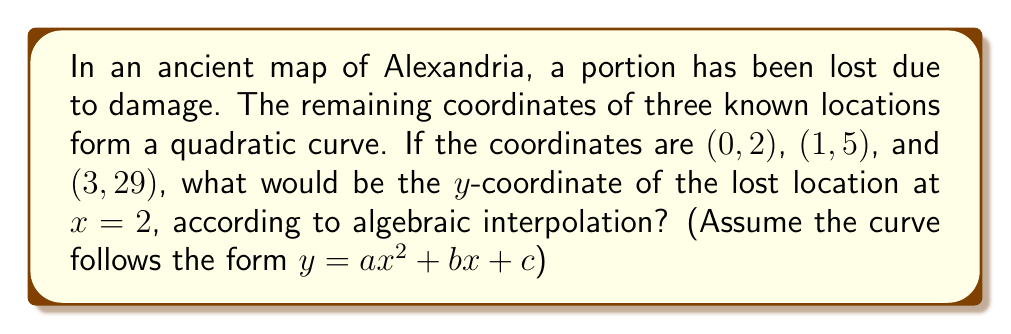Provide a solution to this math problem. To solve this problem, we'll use Lagrange interpolation to reconstruct the quadratic function:

1. Set up the general form of the quadratic: $y = ax^2 + bx + c$

2. Use the three known points to create a system of equations:
   $2 = a(0)^2 + b(0) + c$
   $5 = a(1)^2 + b(1) + c$
   $29 = a(3)^2 + b(3) + c$

3. Simplify:
   $2 = c$
   $5 = a + b + 2$
   $29 = 9a + 3b + 2$

4. Subtract the first equation from the second:
   $3 = a + b$

5. Subtract the first equation from the third:
   $27 = 9a + 3b$

6. Multiply equation from step 4 by 3:
   $9 = 3a + 3b$

7. Subtract this from the equation in step 5:
   $18 = 6a$
   $a = 3$

8. Substitute $a = 3$ into the equation from step 4:
   $3 = 3 + b$
   $b = 0$

9. We now have $a = 3$, $b = 0$, and $c = 2$

10. The reconstructed quadratic is: $y = 3x^2 + 2$

11. To find the y-coordinate at x = 2:
    $y = 3(2)^2 + 2 = 3(4) + 2 = 12 + 2 = 14$
Answer: 14 